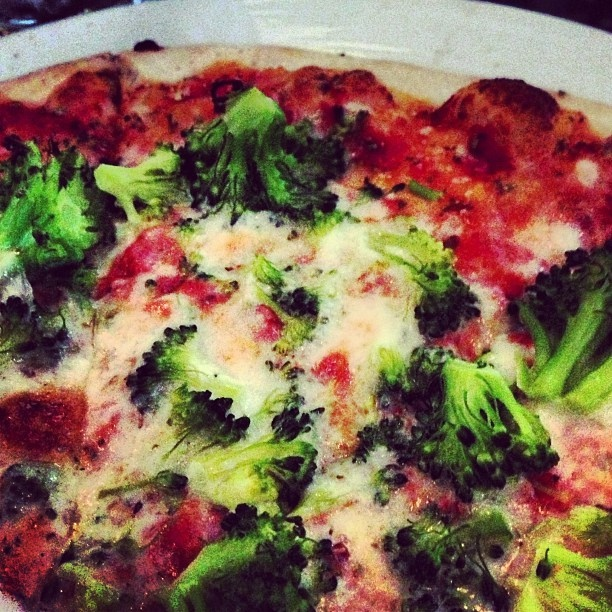Describe the objects in this image and their specific colors. I can see pizza in black, purple, maroon, khaki, and brown tones, broccoli in purple, black, darkgreen, and green tones, bowl in purple, lightgray, and darkgray tones, broccoli in purple, black, olive, khaki, and darkgreen tones, and broccoli in purple, black, darkgreen, and gray tones in this image. 